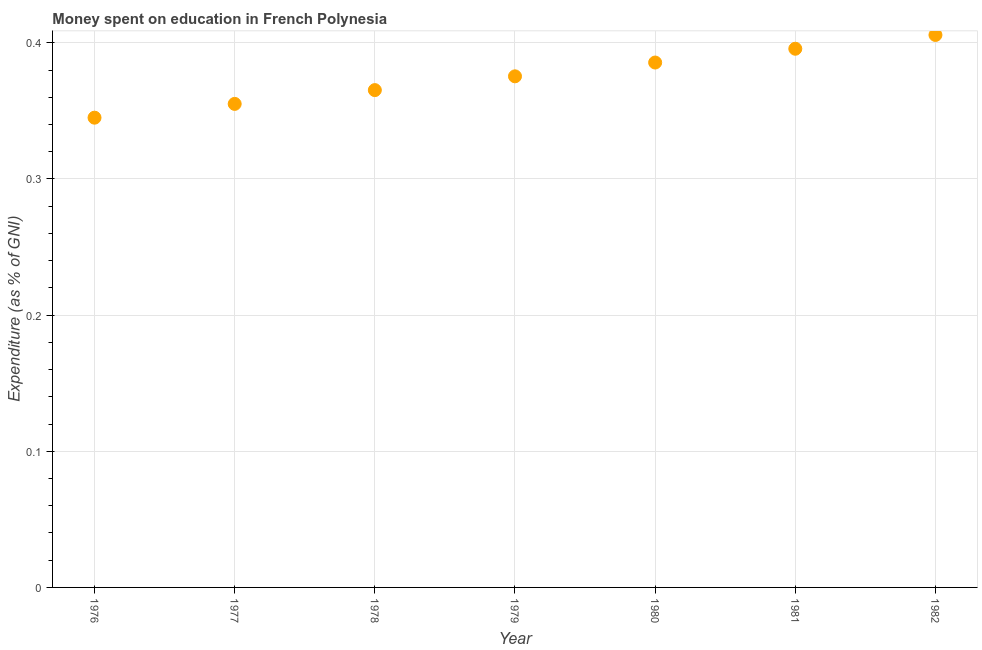What is the expenditure on education in 1979?
Ensure brevity in your answer.  0.38. Across all years, what is the maximum expenditure on education?
Give a very brief answer. 0.41. Across all years, what is the minimum expenditure on education?
Give a very brief answer. 0.35. In which year was the expenditure on education minimum?
Ensure brevity in your answer.  1976. What is the sum of the expenditure on education?
Your response must be concise. 2.63. What is the difference between the expenditure on education in 1980 and 1982?
Your response must be concise. -0.02. What is the average expenditure on education per year?
Ensure brevity in your answer.  0.38. What is the median expenditure on education?
Your answer should be very brief. 0.38. Do a majority of the years between 1979 and 1977 (inclusive) have expenditure on education greater than 0.1 %?
Offer a terse response. No. What is the ratio of the expenditure on education in 1978 to that in 1980?
Your response must be concise. 0.95. What is the difference between the highest and the second highest expenditure on education?
Provide a short and direct response. 0.01. Is the sum of the expenditure on education in 1976 and 1979 greater than the maximum expenditure on education across all years?
Give a very brief answer. Yes. What is the difference between the highest and the lowest expenditure on education?
Ensure brevity in your answer.  0.06. Does the expenditure on education monotonically increase over the years?
Keep it short and to the point. Yes. How many years are there in the graph?
Make the answer very short. 7. What is the difference between two consecutive major ticks on the Y-axis?
Your answer should be compact. 0.1. Are the values on the major ticks of Y-axis written in scientific E-notation?
Provide a succinct answer. No. What is the title of the graph?
Give a very brief answer. Money spent on education in French Polynesia. What is the label or title of the X-axis?
Provide a short and direct response. Year. What is the label or title of the Y-axis?
Offer a terse response. Expenditure (as % of GNI). What is the Expenditure (as % of GNI) in 1976?
Provide a short and direct response. 0.35. What is the Expenditure (as % of GNI) in 1977?
Keep it short and to the point. 0.36. What is the Expenditure (as % of GNI) in 1978?
Keep it short and to the point. 0.37. What is the Expenditure (as % of GNI) in 1979?
Make the answer very short. 0.38. What is the Expenditure (as % of GNI) in 1980?
Your response must be concise. 0.39. What is the Expenditure (as % of GNI) in 1981?
Offer a terse response. 0.4. What is the Expenditure (as % of GNI) in 1982?
Offer a terse response. 0.41. What is the difference between the Expenditure (as % of GNI) in 1976 and 1977?
Make the answer very short. -0.01. What is the difference between the Expenditure (as % of GNI) in 1976 and 1978?
Provide a short and direct response. -0.02. What is the difference between the Expenditure (as % of GNI) in 1976 and 1979?
Your answer should be compact. -0.03. What is the difference between the Expenditure (as % of GNI) in 1976 and 1980?
Offer a terse response. -0.04. What is the difference between the Expenditure (as % of GNI) in 1976 and 1981?
Make the answer very short. -0.05. What is the difference between the Expenditure (as % of GNI) in 1976 and 1982?
Provide a succinct answer. -0.06. What is the difference between the Expenditure (as % of GNI) in 1977 and 1978?
Give a very brief answer. -0.01. What is the difference between the Expenditure (as % of GNI) in 1977 and 1979?
Your answer should be compact. -0.02. What is the difference between the Expenditure (as % of GNI) in 1977 and 1980?
Offer a terse response. -0.03. What is the difference between the Expenditure (as % of GNI) in 1977 and 1981?
Ensure brevity in your answer.  -0.04. What is the difference between the Expenditure (as % of GNI) in 1977 and 1982?
Offer a terse response. -0.05. What is the difference between the Expenditure (as % of GNI) in 1978 and 1979?
Your answer should be very brief. -0.01. What is the difference between the Expenditure (as % of GNI) in 1978 and 1980?
Provide a succinct answer. -0.02. What is the difference between the Expenditure (as % of GNI) in 1978 and 1981?
Your answer should be compact. -0.03. What is the difference between the Expenditure (as % of GNI) in 1978 and 1982?
Your response must be concise. -0.04. What is the difference between the Expenditure (as % of GNI) in 1979 and 1980?
Provide a short and direct response. -0.01. What is the difference between the Expenditure (as % of GNI) in 1979 and 1981?
Provide a succinct answer. -0.02. What is the difference between the Expenditure (as % of GNI) in 1979 and 1982?
Offer a very short reply. -0.03. What is the difference between the Expenditure (as % of GNI) in 1980 and 1981?
Offer a very short reply. -0.01. What is the difference between the Expenditure (as % of GNI) in 1980 and 1982?
Keep it short and to the point. -0.02. What is the difference between the Expenditure (as % of GNI) in 1981 and 1982?
Provide a short and direct response. -0.01. What is the ratio of the Expenditure (as % of GNI) in 1976 to that in 1977?
Make the answer very short. 0.97. What is the ratio of the Expenditure (as % of GNI) in 1976 to that in 1978?
Make the answer very short. 0.94. What is the ratio of the Expenditure (as % of GNI) in 1976 to that in 1979?
Offer a very short reply. 0.92. What is the ratio of the Expenditure (as % of GNI) in 1976 to that in 1980?
Give a very brief answer. 0.9. What is the ratio of the Expenditure (as % of GNI) in 1976 to that in 1981?
Give a very brief answer. 0.87. What is the ratio of the Expenditure (as % of GNI) in 1977 to that in 1978?
Make the answer very short. 0.97. What is the ratio of the Expenditure (as % of GNI) in 1977 to that in 1979?
Give a very brief answer. 0.95. What is the ratio of the Expenditure (as % of GNI) in 1977 to that in 1980?
Keep it short and to the point. 0.92. What is the ratio of the Expenditure (as % of GNI) in 1977 to that in 1981?
Make the answer very short. 0.9. What is the ratio of the Expenditure (as % of GNI) in 1977 to that in 1982?
Offer a very short reply. 0.88. What is the ratio of the Expenditure (as % of GNI) in 1978 to that in 1980?
Ensure brevity in your answer.  0.95. What is the ratio of the Expenditure (as % of GNI) in 1978 to that in 1981?
Offer a terse response. 0.92. What is the ratio of the Expenditure (as % of GNI) in 1979 to that in 1980?
Offer a very short reply. 0.97. What is the ratio of the Expenditure (as % of GNI) in 1979 to that in 1981?
Your answer should be very brief. 0.95. What is the ratio of the Expenditure (as % of GNI) in 1979 to that in 1982?
Keep it short and to the point. 0.93. What is the ratio of the Expenditure (as % of GNI) in 1980 to that in 1981?
Your response must be concise. 0.97. What is the ratio of the Expenditure (as % of GNI) in 1980 to that in 1982?
Give a very brief answer. 0.95. 